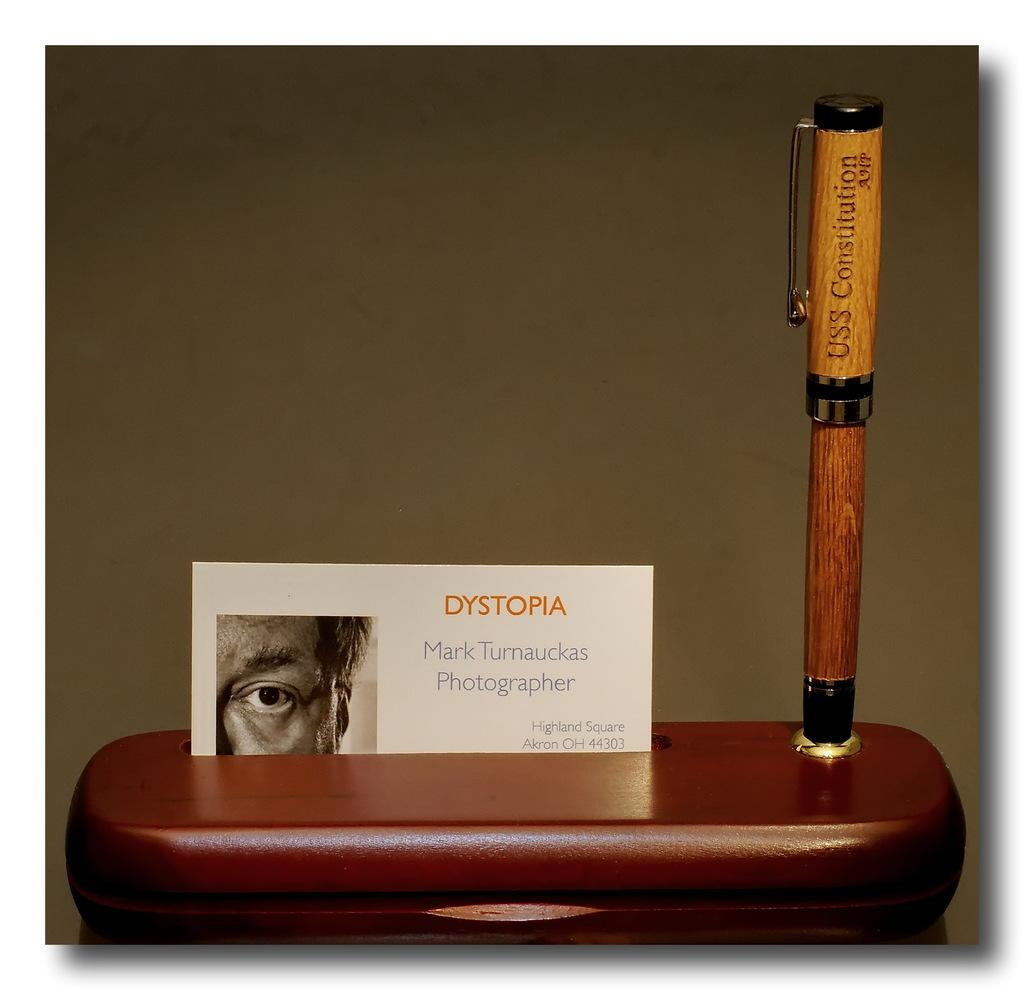What is depicted on the card in the image? There is a card with a picture and text in the image. What object is placed on the surface in the image? There is a pen placed on the surface in the image. What can be seen in the background of the image? There is a wall in the background of the image. Is there a chair in the image that the person is sitting on while taking a test? There is no chair or person taking a test present in the image. What type of love is expressed in the image? There is no expression of love in the image, as it only features a card, a pen, and a wall in the background. 